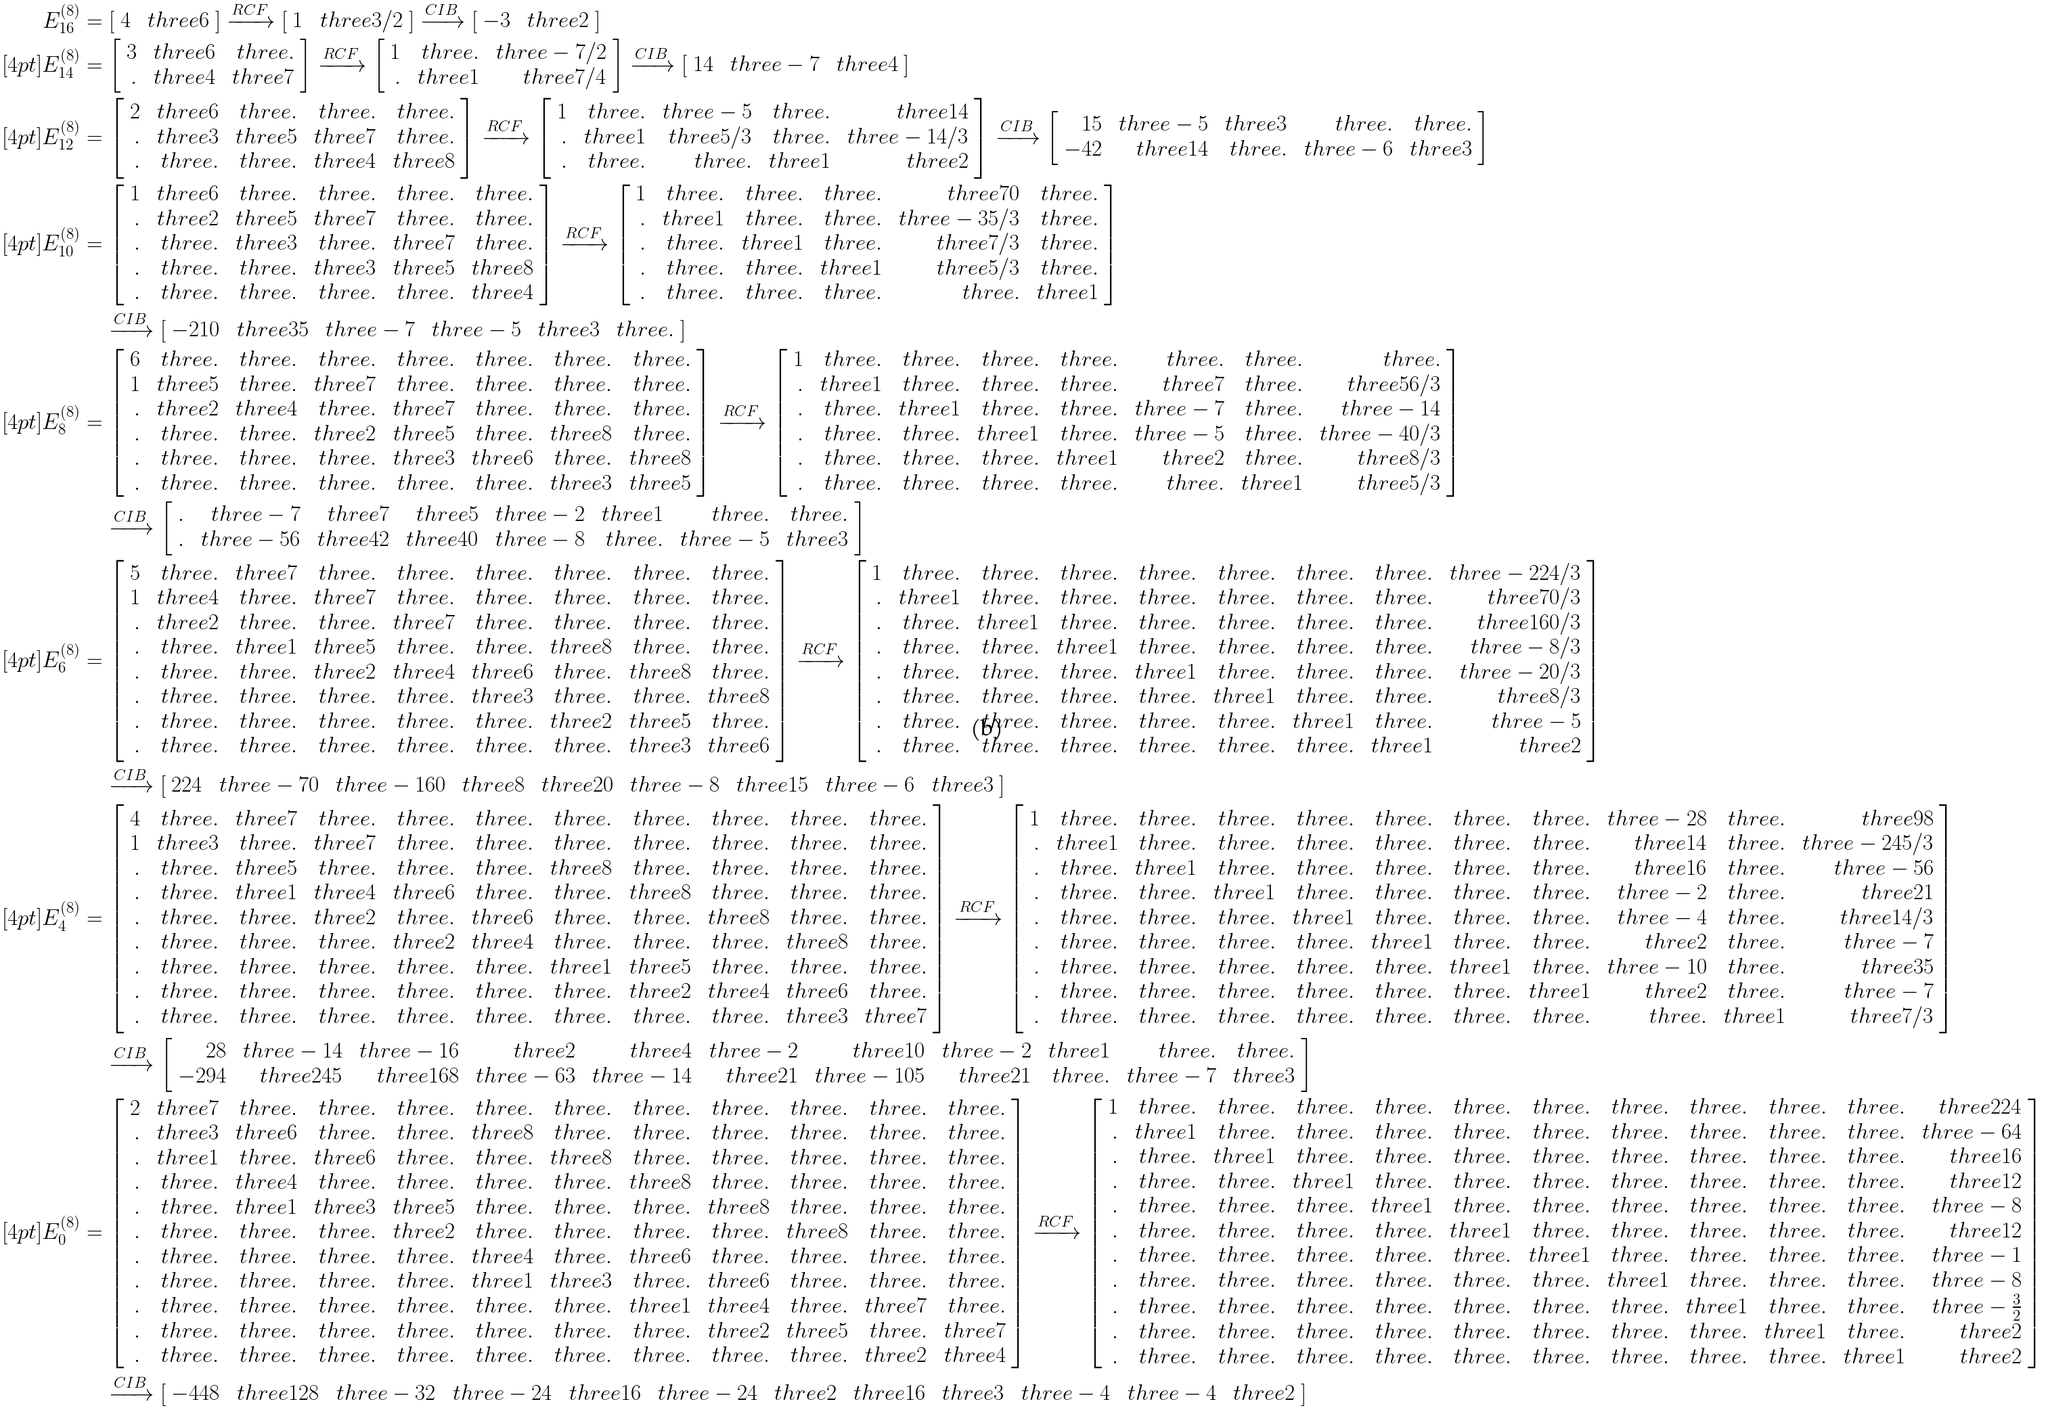Convert formula to latex. <formula><loc_0><loc_0><loc_500><loc_500>E ^ { ( 8 ) } _ { 1 6 } & = \left [ \begin{array} { r r } 4 & \ t h r e e 6 \end{array} \right ] \xrightarrow { R C F } \left [ \begin{array} { r r } 1 & \ t h r e e 3 / 2 \end{array} \right ] \xrightarrow { C I B } \left [ \begin{array} { r r } - 3 & \ t h r e e 2 \end{array} \right ] \\ [ 4 p t ] E ^ { ( 8 ) } _ { 1 4 } & = \left [ \begin{array} { r r r } 3 & \ t h r e e 6 & \ t h r e e . \\ . & \ t h r e e 4 & \ t h r e e 7 \end{array} \right ] \xrightarrow { R C F } \left [ \begin{array} { r r r } 1 & \ t h r e e . & \ t h r e e - 7 / 2 \\ . & \ t h r e e 1 & \ t h r e e 7 / 4 \end{array} \right ] \xrightarrow { C I B } \left [ \begin{array} { r r r } 1 4 & \ t h r e e - 7 & \ t h r e e 4 \end{array} \right ] \\ [ 4 p t ] E ^ { ( 8 ) } _ { 1 2 } & = \left [ \begin{array} { r r r r r } 2 & \ t h r e e 6 & \ t h r e e . & \ t h r e e . & \ t h r e e . \\ . & \ t h r e e 3 & \ t h r e e 5 & \ t h r e e 7 & \ t h r e e . \\ . & \ t h r e e . & \ t h r e e . & \ t h r e e 4 & \ t h r e e 8 \end{array} \right ] \xrightarrow { R C F } \left [ \begin{array} { r r r r r } 1 & \ t h r e e . & \ t h r e e - 5 & \ t h r e e . & \ t h r e e 1 4 \\ . & \ t h r e e 1 & \ t h r e e 5 / 3 & \ t h r e e . & \ t h r e e - 1 4 / 3 \\ . & \ t h r e e . & \ t h r e e . & \ t h r e e 1 & \ t h r e e 2 \end{array} \right ] \xrightarrow { C I B } \left [ \begin{array} { r r r r r } 1 5 & \ t h r e e - 5 & \ t h r e e 3 & \ t h r e e . & \ t h r e e . \\ - 4 2 & \ t h r e e 1 4 & \ t h r e e . & \ t h r e e - 6 & \ t h r e e 3 \end{array} \right ] \\ [ 4 p t ] E ^ { ( 8 ) } _ { 1 0 } & = \left [ \begin{array} { r r r r r r } 1 & \ t h r e e 6 & \ t h r e e . & \ t h r e e . & \ t h r e e . & \ t h r e e . \\ . & \ t h r e e 2 & \ t h r e e 5 & \ t h r e e 7 & \ t h r e e . & \ t h r e e . \\ . & \ t h r e e . & \ t h r e e 3 & \ t h r e e . & \ t h r e e 7 & \ t h r e e . \\ . & \ t h r e e . & \ t h r e e . & \ t h r e e 3 & \ t h r e e 5 & \ t h r e e 8 \\ . & \ t h r e e . & \ t h r e e . & \ t h r e e . & \ t h r e e . & \ t h r e e 4 \end{array} \right ] \xrightarrow { R C F } \left [ \begin{array} { r r r r r r } 1 & \ t h r e e . & \ t h r e e . & \ t h r e e . & \ t h r e e 7 0 & \ t h r e e . \\ . & \ t h r e e 1 & \ t h r e e . & \ t h r e e . & \ t h r e e - 3 5 / 3 & \ t h r e e . \\ . & \ t h r e e . & \ t h r e e 1 & \ t h r e e . & \ t h r e e 7 / 3 & \ t h r e e . \\ . & \ t h r e e . & \ t h r e e . & \ t h r e e 1 & \ t h r e e 5 / 3 & \ t h r e e . \\ . & \ t h r e e . & \ t h r e e . & \ t h r e e . & \ t h r e e . & \ t h r e e 1 \end{array} \right ] \\ & \quad \xrightarrow { C I B } \left [ \begin{array} { r r r r r r } - 2 1 0 & \ t h r e e 3 5 & \ t h r e e - 7 & \ t h r e e - 5 & \ t h r e e 3 & \ t h r e e . \end{array} \right ] \\ [ 4 p t ] E ^ { ( 8 ) } _ { 8 } & = \left [ \begin{array} { r r r r r r r r } 6 & \ t h r e e . & \ t h r e e . & \ t h r e e . & \ t h r e e . & \ t h r e e . & \ t h r e e . & \ t h r e e . \\ 1 & \ t h r e e 5 & \ t h r e e . & \ t h r e e 7 & \ t h r e e . & \ t h r e e . & \ t h r e e . & \ t h r e e . \\ . & \ t h r e e 2 & \ t h r e e 4 & \ t h r e e . & \ t h r e e 7 & \ t h r e e . & \ t h r e e . & \ t h r e e . \\ . & \ t h r e e . & \ t h r e e . & \ t h r e e 2 & \ t h r e e 5 & \ t h r e e . & \ t h r e e 8 & \ t h r e e . \\ . & \ t h r e e . & \ t h r e e . & \ t h r e e . & \ t h r e e 3 & \ t h r e e 6 & \ t h r e e . & \ t h r e e 8 \\ . & \ t h r e e . & \ t h r e e . & \ t h r e e . & \ t h r e e . & \ t h r e e . & \ t h r e e 3 & \ t h r e e 5 \end{array} \right ] \xrightarrow { R C F } \left [ \begin{array} { r r r r r r r r } 1 & \ t h r e e . & \ t h r e e . & \ t h r e e . & \ t h r e e . & \ t h r e e . & \ t h r e e . & \ t h r e e . \\ . & \ t h r e e 1 & \ t h r e e . & \ t h r e e . & \ t h r e e . & \ t h r e e 7 & \ t h r e e . & \ t h r e e 5 6 / 3 \\ . & \ t h r e e . & \ t h r e e 1 & \ t h r e e . & \ t h r e e . & \ t h r e e - 7 & \ t h r e e . & \ t h r e e - 1 4 \\ . & \ t h r e e . & \ t h r e e . & \ t h r e e 1 & \ t h r e e . & \ t h r e e - 5 & \ t h r e e . & \ t h r e e - 4 0 / 3 \\ . & \ t h r e e . & \ t h r e e . & \ t h r e e . & \ t h r e e 1 & \ t h r e e 2 & \ t h r e e . & \ t h r e e 8 / 3 \\ . & \ t h r e e . & \ t h r e e . & \ t h r e e . & \ t h r e e . & \ t h r e e . & \ t h r e e 1 & \ t h r e e 5 / 3 \end{array} \right ] \\ & \quad \xrightarrow { C I B } \left [ \begin{array} { r r r r r r r r } . & \ t h r e e - 7 & \ t h r e e 7 & \ t h r e e 5 & \ t h r e e - 2 & \ t h r e e 1 & \ t h r e e . & \ t h r e e . \\ . & \ t h r e e - 5 6 & \ t h r e e 4 2 & \ t h r e e 4 0 & \ t h r e e - 8 & \ t h r e e . & \ t h r e e - 5 & \ t h r e e 3 \end{array} \right ] \\ [ 4 p t ] E ^ { ( 8 ) } _ { 6 } & = \left [ \begin{array} { r r r r r r r r r } 5 & \ t h r e e . & \ t h r e e 7 & \ t h r e e . & \ t h r e e . & \ t h r e e . & \ t h r e e . & \ t h r e e . & \ t h r e e . \\ 1 & \ t h r e e 4 & \ t h r e e . & \ t h r e e 7 & \ t h r e e . & \ t h r e e . & \ t h r e e . & \ t h r e e . & \ t h r e e . \\ . & \ t h r e e 2 & \ t h r e e . & \ t h r e e . & \ t h r e e 7 & \ t h r e e . & \ t h r e e . & \ t h r e e . & \ t h r e e . \\ . & \ t h r e e . & \ t h r e e 1 & \ t h r e e 5 & \ t h r e e . & \ t h r e e . & \ t h r e e 8 & \ t h r e e . & \ t h r e e . \\ . & \ t h r e e . & \ t h r e e . & \ t h r e e 2 & \ t h r e e 4 & \ t h r e e 6 & \ t h r e e . & \ t h r e e 8 & \ t h r e e . \\ . & \ t h r e e . & \ t h r e e . & \ t h r e e . & \ t h r e e . & \ t h r e e 3 & \ t h r e e . & \ t h r e e . & \ t h r e e 8 \\ . & \ t h r e e . & \ t h r e e . & \ t h r e e . & \ t h r e e . & \ t h r e e . & \ t h r e e 2 & \ t h r e e 5 & \ t h r e e . \\ . & \ t h r e e . & \ t h r e e . & \ t h r e e . & \ t h r e e . & \ t h r e e . & \ t h r e e . & \ t h r e e 3 & \ t h r e e 6 \end{array} \right ] \xrightarrow { R C F } \left [ \begin{array} { r r r r r r r r r } 1 & \ t h r e e . & \ t h r e e . & \ t h r e e . & \ t h r e e . & \ t h r e e . & \ t h r e e . & \ t h r e e . & \ t h r e e - 2 2 4 / 3 \\ . & \ t h r e e 1 & \ t h r e e . & \ t h r e e . & \ t h r e e . & \ t h r e e . & \ t h r e e . & \ t h r e e . & \ t h r e e 7 0 / 3 \\ . & \ t h r e e . & \ t h r e e 1 & \ t h r e e . & \ t h r e e . & \ t h r e e . & \ t h r e e . & \ t h r e e . & \ t h r e e 1 6 0 / 3 \\ . & \ t h r e e . & \ t h r e e . & \ t h r e e 1 & \ t h r e e . & \ t h r e e . & \ t h r e e . & \ t h r e e . & \ t h r e e - 8 / 3 \\ . & \ t h r e e . & \ t h r e e . & \ t h r e e . & \ t h r e e 1 & \ t h r e e . & \ t h r e e . & \ t h r e e . & \ t h r e e - 2 0 / 3 \\ . & \ t h r e e . & \ t h r e e . & \ t h r e e . & \ t h r e e . & \ t h r e e 1 & \ t h r e e . & \ t h r e e . & \ t h r e e 8 / 3 \\ . & \ t h r e e . & \ t h r e e . & \ t h r e e . & \ t h r e e . & \ t h r e e . & \ t h r e e 1 & \ t h r e e . & \ t h r e e - 5 \\ . & \ t h r e e . & \ t h r e e . & \ t h r e e . & \ t h r e e . & \ t h r e e . & \ t h r e e . & \ t h r e e 1 & \ t h r e e 2 \end{array} \right ] \\ & \quad \xrightarrow { C I B } \left [ \begin{array} { r r r r r r r r r } 2 2 4 & \ t h r e e - 7 0 & \ t h r e e - 1 6 0 & \ t h r e e 8 & \ t h r e e 2 0 & \ t h r e e - 8 & \ t h r e e 1 5 & \ t h r e e - 6 & \ t h r e e 3 \end{array} \right ] \\ [ 4 p t ] E ^ { ( 8 ) } _ { 4 } & = \left [ \begin{array} { r r r r r r r r r r r } 4 & \ t h r e e . & \ t h r e e 7 & \ t h r e e . & \ t h r e e . & \ t h r e e . & \ t h r e e . & \ t h r e e . & \ t h r e e . & \ t h r e e . & \ t h r e e . \\ 1 & \ t h r e e 3 & \ t h r e e . & \ t h r e e 7 & \ t h r e e . & \ t h r e e . & \ t h r e e . & \ t h r e e . & \ t h r e e . & \ t h r e e . & \ t h r e e . \\ . & \ t h r e e . & \ t h r e e 5 & \ t h r e e . & \ t h r e e . & \ t h r e e . & \ t h r e e 8 & \ t h r e e . & \ t h r e e . & \ t h r e e . & \ t h r e e . \\ . & \ t h r e e . & \ t h r e e 1 & \ t h r e e 4 & \ t h r e e 6 & \ t h r e e . & \ t h r e e . & \ t h r e e 8 & \ t h r e e . & \ t h r e e . & \ t h r e e . \\ . & \ t h r e e . & \ t h r e e . & \ t h r e e 2 & \ t h r e e . & \ t h r e e 6 & \ t h r e e . & \ t h r e e . & \ t h r e e 8 & \ t h r e e . & \ t h r e e . \\ . & \ t h r e e . & \ t h r e e . & \ t h r e e . & \ t h r e e 2 & \ t h r e e 4 & \ t h r e e . & \ t h r e e . & \ t h r e e . & \ t h r e e 8 & \ t h r e e . \\ . & \ t h r e e . & \ t h r e e . & \ t h r e e . & \ t h r e e . & \ t h r e e . & \ t h r e e 1 & \ t h r e e 5 & \ t h r e e . & \ t h r e e . & \ t h r e e . \\ . & \ t h r e e . & \ t h r e e . & \ t h r e e . & \ t h r e e . & \ t h r e e . & \ t h r e e . & \ t h r e e 2 & \ t h r e e 4 & \ t h r e e 6 & \ t h r e e . \\ . & \ t h r e e . & \ t h r e e . & \ t h r e e . & \ t h r e e . & \ t h r e e . & \ t h r e e . & \ t h r e e . & \ t h r e e . & \ t h r e e 3 & \ t h r e e 7 \end{array} \right ] \xrightarrow { R C F } \left [ \begin{array} { r r r r r r r r r r r } 1 & \ t h r e e . & \ t h r e e . & \ t h r e e . & \ t h r e e . & \ t h r e e . & \ t h r e e . & \ t h r e e . & \ t h r e e - 2 8 & \ t h r e e . & \ t h r e e 9 8 \\ . & \ t h r e e 1 & \ t h r e e . & \ t h r e e . & \ t h r e e . & \ t h r e e . & \ t h r e e . & \ t h r e e . & \ t h r e e 1 4 & \ t h r e e . & \ t h r e e - 2 4 5 / 3 \\ . & \ t h r e e . & \ t h r e e 1 & \ t h r e e . & \ t h r e e . & \ t h r e e . & \ t h r e e . & \ t h r e e . & \ t h r e e 1 6 & \ t h r e e . & \ t h r e e - 5 6 \\ . & \ t h r e e . & \ t h r e e . & \ t h r e e 1 & \ t h r e e . & \ t h r e e . & \ t h r e e . & \ t h r e e . & \ t h r e e - 2 & \ t h r e e . & \ t h r e e 2 1 \\ . & \ t h r e e . & \ t h r e e . & \ t h r e e . & \ t h r e e 1 & \ t h r e e . & \ t h r e e . & \ t h r e e . & \ t h r e e - 4 & \ t h r e e . & \ t h r e e 1 4 / 3 \\ . & \ t h r e e . & \ t h r e e . & \ t h r e e . & \ t h r e e . & \ t h r e e 1 & \ t h r e e . & \ t h r e e . & \ t h r e e 2 & \ t h r e e . & \ t h r e e - 7 \\ . & \ t h r e e . & \ t h r e e . & \ t h r e e . & \ t h r e e . & \ t h r e e . & \ t h r e e 1 & \ t h r e e . & \ t h r e e - 1 0 & \ t h r e e . & \ t h r e e 3 5 \\ . & \ t h r e e . & \ t h r e e . & \ t h r e e . & \ t h r e e . & \ t h r e e . & \ t h r e e . & \ t h r e e 1 & \ t h r e e 2 & \ t h r e e . & \ t h r e e - 7 \\ . & \ t h r e e . & \ t h r e e . & \ t h r e e . & \ t h r e e . & \ t h r e e . & \ t h r e e . & \ t h r e e . & \ t h r e e . & \ t h r e e 1 & \ t h r e e 7 / 3 \\ \end{array} \right ] \\ & \quad \xrightarrow { C I B } \left [ \begin{array} { r r r r r r r r r r r } 2 8 & \ t h r e e - 1 4 & \ t h r e e - 1 6 & \ t h r e e 2 & \ t h r e e 4 & \ t h r e e - 2 & \ t h r e e 1 0 & \ t h r e e - 2 & \ t h r e e 1 & \ t h r e e . & \ t h r e e . \\ - 2 9 4 & \ t h r e e 2 4 5 & \ t h r e e 1 6 8 & \ t h r e e - 6 3 & \ t h r e e - 1 4 & \ t h r e e 2 1 & \ t h r e e - 1 0 5 & \ t h r e e 2 1 & \ t h r e e . & \ t h r e e - 7 & \ t h r e e 3 \end{array} \right ] \\ [ 4 p t ] E ^ { ( 8 ) } _ { 0 } & = \left [ \begin{array} { r r r r r r r r r r r r } 2 & \ t h r e e 7 & \ t h r e e . & \ t h r e e . & \ t h r e e . & \ t h r e e . & \ t h r e e . & \ t h r e e . & \ t h r e e . & \ t h r e e . & \ t h r e e . & \ t h r e e . \\ . & \ t h r e e 3 & \ t h r e e 6 & \ t h r e e . & \ t h r e e . & \ t h r e e 8 & \ t h r e e . & \ t h r e e . & \ t h r e e . & \ t h r e e . & \ t h r e e . & \ t h r e e . \\ . & \ t h r e e 1 & \ t h r e e . & \ t h r e e 6 & \ t h r e e . & \ t h r e e . & \ t h r e e 8 & \ t h r e e . & \ t h r e e . & \ t h r e e . & \ t h r e e . & \ t h r e e . \\ . & \ t h r e e . & \ t h r e e 4 & \ t h r e e . & \ t h r e e . & \ t h r e e . & \ t h r e e . & \ t h r e e 8 & \ t h r e e . & \ t h r e e . & \ t h r e e . & \ t h r e e . \\ . & \ t h r e e . & \ t h r e e 1 & \ t h r e e 3 & \ t h r e e 5 & \ t h r e e . & \ t h r e e . & \ t h r e e . & \ t h r e e 8 & \ t h r e e . & \ t h r e e . & \ t h r e e . \\ . & \ t h r e e . & \ t h r e e . & \ t h r e e . & \ t h r e e 2 & \ t h r e e . & \ t h r e e . & \ t h r e e . & \ t h r e e . & \ t h r e e 8 & \ t h r e e . & \ t h r e e . \\ . & \ t h r e e . & \ t h r e e . & \ t h r e e . & \ t h r e e . & \ t h r e e 4 & \ t h r e e . & \ t h r e e 6 & \ t h r e e . & \ t h r e e . & \ t h r e e . & \ t h r e e . \\ . & \ t h r e e . & \ t h r e e . & \ t h r e e . & \ t h r e e . & \ t h r e e 1 & \ t h r e e 3 & \ t h r e e . & \ t h r e e 6 & \ t h r e e . & \ t h r e e . & \ t h r e e . \\ . & \ t h r e e . & \ t h r e e . & \ t h r e e . & \ t h r e e . & \ t h r e e . & \ t h r e e . & \ t h r e e 1 & \ t h r e e 4 & \ t h r e e . & \ t h r e e 7 & \ t h r e e . \\ . & \ t h r e e . & \ t h r e e . & \ t h r e e . & \ t h r e e . & \ t h r e e . & \ t h r e e . & \ t h r e e . & \ t h r e e 2 & \ t h r e e 5 & \ t h r e e . & \ t h r e e 7 \\ . & \ t h r e e . & \ t h r e e . & \ t h r e e . & \ t h r e e . & \ t h r e e . & \ t h r e e . & \ t h r e e . & \ t h r e e . & \ t h r e e . & \ t h r e e 2 & \ t h r e e 4 \end{array} \right ] \xrightarrow { R C F } \left [ \begin{array} { r r r r r r r r r r r r } 1 & \ t h r e e . & \ t h r e e . & \ t h r e e . & \ t h r e e . & \ t h r e e . & \ t h r e e . & \ t h r e e . & \ t h r e e . & \ t h r e e . & \ t h r e e . & \ t h r e e 2 2 4 \\ . & \ t h r e e 1 & \ t h r e e . & \ t h r e e . & \ t h r e e . & \ t h r e e . & \ t h r e e . & \ t h r e e . & \ t h r e e . & \ t h r e e . & \ t h r e e . & \ t h r e e - 6 4 \\ . & \ t h r e e . & \ t h r e e 1 & \ t h r e e . & \ t h r e e . & \ t h r e e . & \ t h r e e . & \ t h r e e . & \ t h r e e . & \ t h r e e . & \ t h r e e . & \ t h r e e 1 6 \\ . & \ t h r e e . & \ t h r e e . & \ t h r e e 1 & \ t h r e e . & \ t h r e e . & \ t h r e e . & \ t h r e e . & \ t h r e e . & \ t h r e e . & \ t h r e e . & \ t h r e e 1 2 \\ . & \ t h r e e . & \ t h r e e . & \ t h r e e . & \ t h r e e 1 & \ t h r e e . & \ t h r e e . & \ t h r e e . & \ t h r e e . & \ t h r e e . & \ t h r e e . & \ t h r e e - 8 \\ . & \ t h r e e . & \ t h r e e . & \ t h r e e . & \ t h r e e . & \ t h r e e 1 & \ t h r e e . & \ t h r e e . & \ t h r e e . & \ t h r e e . & \ t h r e e . & \ t h r e e 1 2 \\ . & \ t h r e e . & \ t h r e e . & \ t h r e e . & \ t h r e e . & \ t h r e e . & \ t h r e e 1 & \ t h r e e . & \ t h r e e . & \ t h r e e . & \ t h r e e . & \ t h r e e - 1 \\ . & \ t h r e e . & \ t h r e e . & \ t h r e e . & \ t h r e e . & \ t h r e e . & \ t h r e e . & \ t h r e e 1 & \ t h r e e . & \ t h r e e . & \ t h r e e . & \ t h r e e - 8 \\ . & \ t h r e e . & \ t h r e e . & \ t h r e e . & \ t h r e e . & \ t h r e e . & \ t h r e e . & \ t h r e e . & \ t h r e e 1 & \ t h r e e . & \ t h r e e . & \ t h r e e - \frac { 3 } { 2 } \\ . & \ t h r e e . & \ t h r e e . & \ t h r e e . & \ t h r e e . & \ t h r e e . & \ t h r e e . & \ t h r e e . & \ t h r e e . & \ t h r e e 1 & \ t h r e e . & \ t h r e e 2 \\ . & \ t h r e e . & \ t h r e e . & \ t h r e e . & \ t h r e e . & \ t h r e e . & \ t h r e e . & \ t h r e e . & \ t h r e e . & \ t h r e e . & \ t h r e e 1 & \ t h r e e 2 \end{array} \right ] \\ & \quad \xrightarrow { C I B } \left [ \begin{array} { r r r r r r r r r r r r } - 4 4 8 & \ t h r e e 1 2 8 & \ t h r e e - 3 2 & \ t h r e e - 2 4 & \ t h r e e 1 6 & \ t h r e e - 2 4 & \ t h r e e 2 & \ t h r e e 1 6 & \ t h r e e 3 & \ t h r e e - 4 & \ t h r e e - 4 & \ t h r e e 2 \end{array} \right ]</formula> 